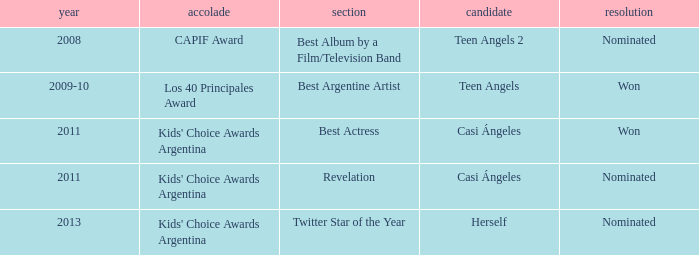In what category was Herself nominated? Twitter Star of the Year. 